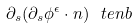<formula> <loc_0><loc_0><loc_500><loc_500>\partial _ { s } ( \partial _ { s } \phi ^ { \epsilon } \cdot n ) \ t e n b</formula> 